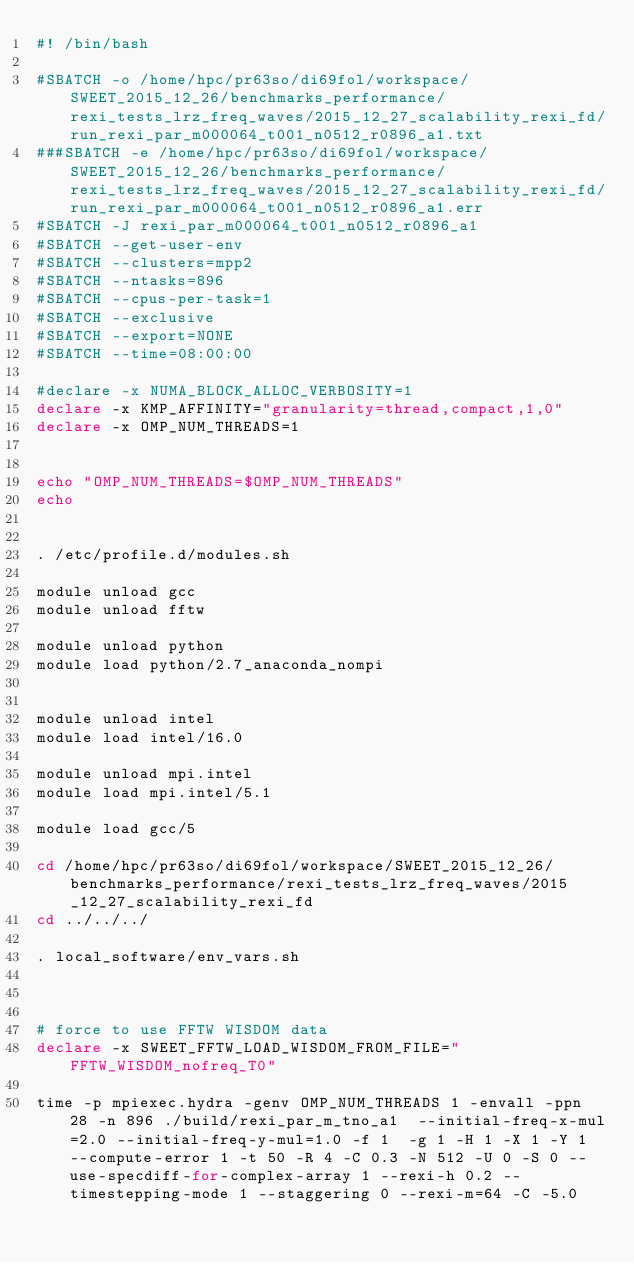<code> <loc_0><loc_0><loc_500><loc_500><_Bash_>#! /bin/bash

#SBATCH -o /home/hpc/pr63so/di69fol/workspace/SWEET_2015_12_26/benchmarks_performance/rexi_tests_lrz_freq_waves/2015_12_27_scalability_rexi_fd/run_rexi_par_m000064_t001_n0512_r0896_a1.txt
###SBATCH -e /home/hpc/pr63so/di69fol/workspace/SWEET_2015_12_26/benchmarks_performance/rexi_tests_lrz_freq_waves/2015_12_27_scalability_rexi_fd/run_rexi_par_m000064_t001_n0512_r0896_a1.err
#SBATCH -J rexi_par_m000064_t001_n0512_r0896_a1
#SBATCH --get-user-env
#SBATCH --clusters=mpp2
#SBATCH --ntasks=896
#SBATCH --cpus-per-task=1
#SBATCH --exclusive
#SBATCH --export=NONE
#SBATCH --time=08:00:00

#declare -x NUMA_BLOCK_ALLOC_VERBOSITY=1
declare -x KMP_AFFINITY="granularity=thread,compact,1,0"
declare -x OMP_NUM_THREADS=1


echo "OMP_NUM_THREADS=$OMP_NUM_THREADS"
echo


. /etc/profile.d/modules.sh

module unload gcc
module unload fftw

module unload python
module load python/2.7_anaconda_nompi


module unload intel
module load intel/16.0

module unload mpi.intel
module load mpi.intel/5.1

module load gcc/5

cd /home/hpc/pr63so/di69fol/workspace/SWEET_2015_12_26/benchmarks_performance/rexi_tests_lrz_freq_waves/2015_12_27_scalability_rexi_fd
cd ../../../

. local_software/env_vars.sh



# force to use FFTW WISDOM data
declare -x SWEET_FFTW_LOAD_WISDOM_FROM_FILE="FFTW_WISDOM_nofreq_T0"

time -p mpiexec.hydra -genv OMP_NUM_THREADS 1 -envall -ppn 28 -n 896 ./build/rexi_par_m_tno_a1  --initial-freq-x-mul=2.0 --initial-freq-y-mul=1.0 -f 1  -g 1 -H 1 -X 1 -Y 1 --compute-error 1 -t 50 -R 4 -C 0.3 -N 512 -U 0 -S 0 --use-specdiff-for-complex-array 1 --rexi-h 0.2 --timestepping-mode 1 --staggering 0 --rexi-m=64 -C -5.0

</code> 